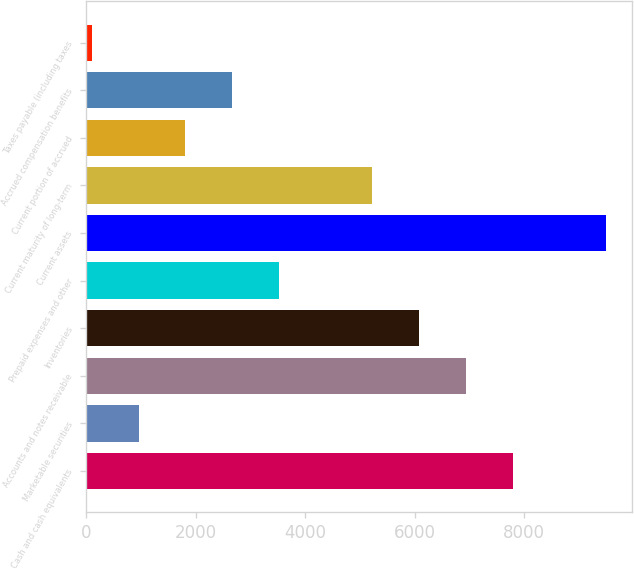Convert chart to OTSL. <chart><loc_0><loc_0><loc_500><loc_500><bar_chart><fcel>Cash and cash equivalents<fcel>Marketable securities<fcel>Accounts and notes receivable<fcel>Inventories<fcel>Prepaid expenses and other<fcel>Current assets<fcel>Current maturity of long-term<fcel>Current portion of accrued<fcel>Accrued compensation benefits<fcel>Taxes payable (including taxes<nl><fcel>7785<fcel>953<fcel>6931<fcel>6077<fcel>3515<fcel>9493<fcel>5223<fcel>1807<fcel>2661<fcel>99<nl></chart> 